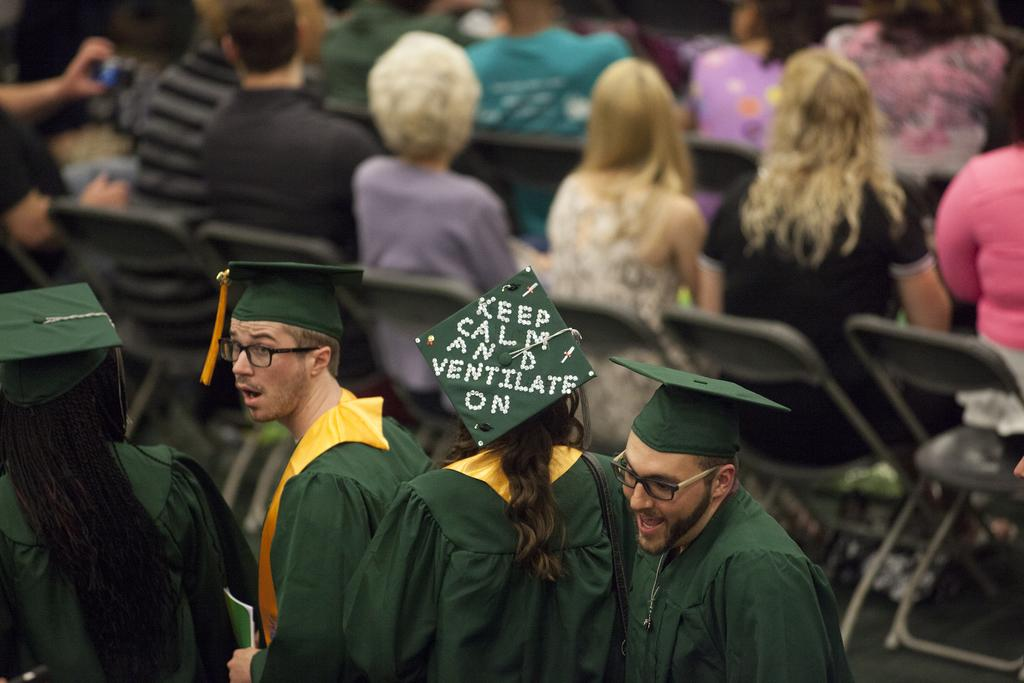How many people are present in the image? There are four people in the image. What are the people wearing in the image? The four people are wearing green dresses. How do the people in the image look? The people appear stunning. What can be seen in the background of the image? There is a group of people sitting in the background. How are the people in the background seated? The people in the background are sitting on chairs. What type of pie is being served to the people in the image? There is no pie present in the image; it features four people wearing green dresses and a group of people sitting in the background. 